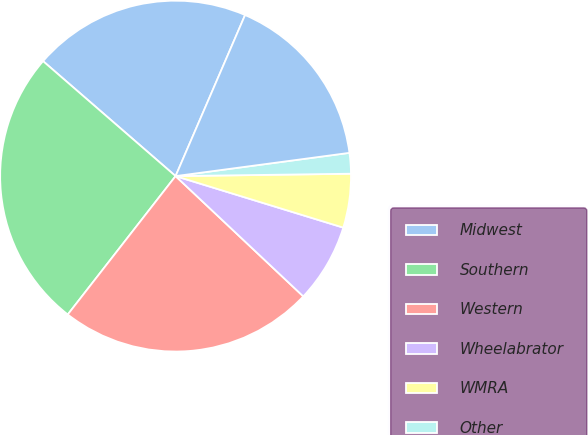Convert chart to OTSL. <chart><loc_0><loc_0><loc_500><loc_500><pie_chart><fcel>Midwest<fcel>Southern<fcel>Western<fcel>Wheelabrator<fcel>WMRA<fcel>Other<fcel>Intercompany<nl><fcel>20.11%<fcel>25.84%<fcel>23.51%<fcel>7.28%<fcel>4.96%<fcel>1.9%<fcel>16.4%<nl></chart> 